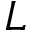Convert formula to latex. <formula><loc_0><loc_0><loc_500><loc_500>L</formula> 